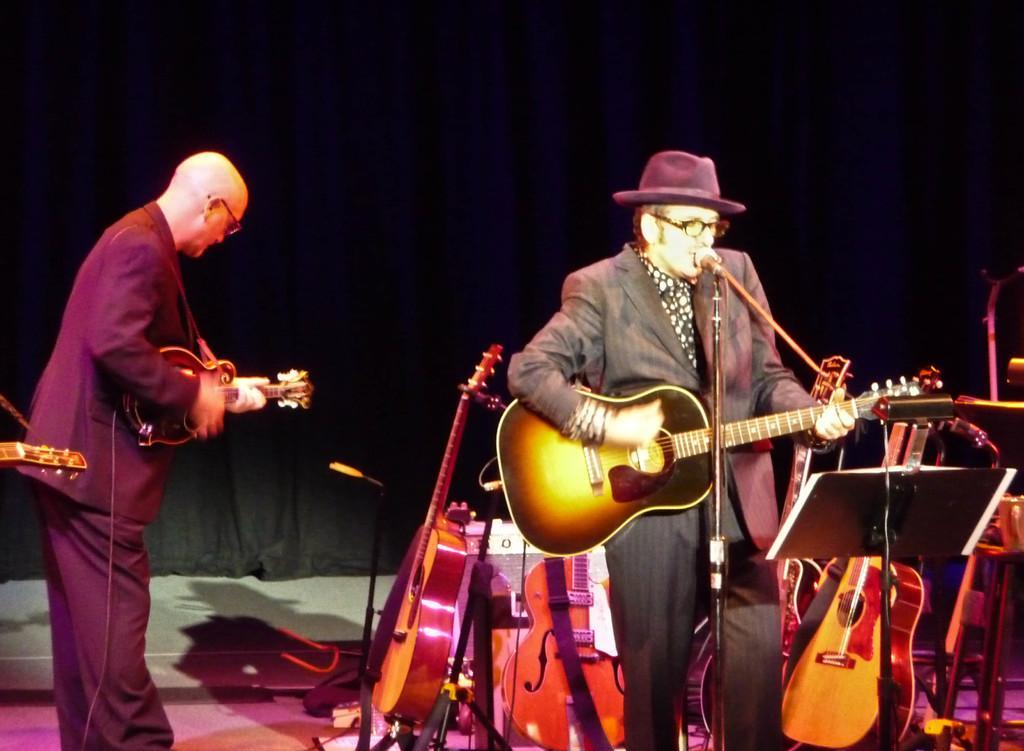Could you give a brief overview of what you see in this image? In this image, two peoples are playing a musical instrument. There are so many musical instruments are placed at the bottom. And the background, we can see a black color curtain. And here we can see book and stand and microphone here. 